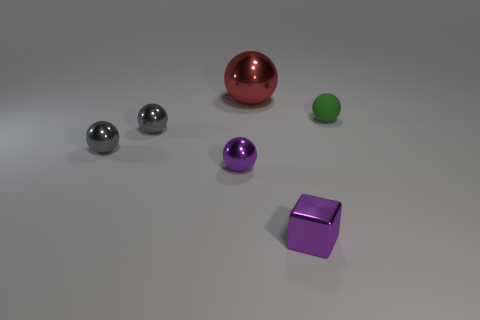Subtract all big red metal spheres. How many spheres are left? 4 Subtract all gray cylinders. How many gray spheres are left? 2 Subtract all red spheres. How many spheres are left? 4 Add 3 small green things. How many objects exist? 9 Subtract all purple spheres. Subtract all cyan cylinders. How many spheres are left? 4 Subtract all balls. How many objects are left? 1 Subtract 0 red cubes. How many objects are left? 6 Subtract all red metal objects. Subtract all gray balls. How many objects are left? 3 Add 3 shiny objects. How many shiny objects are left? 8 Add 4 small metallic spheres. How many small metallic spheres exist? 7 